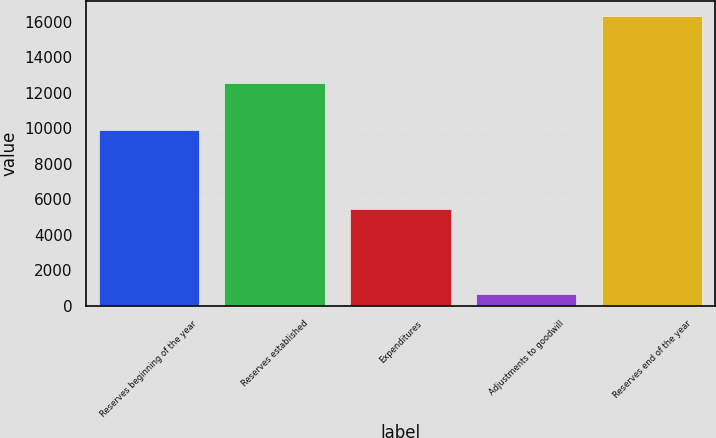Convert chart. <chart><loc_0><loc_0><loc_500><loc_500><bar_chart><fcel>Reserves beginning of the year<fcel>Reserves established<fcel>Expenditures<fcel>Adjustments to goodwill<fcel>Reserves end of the year<nl><fcel>9906<fcel>12526<fcel>5436<fcel>674<fcel>16322<nl></chart> 